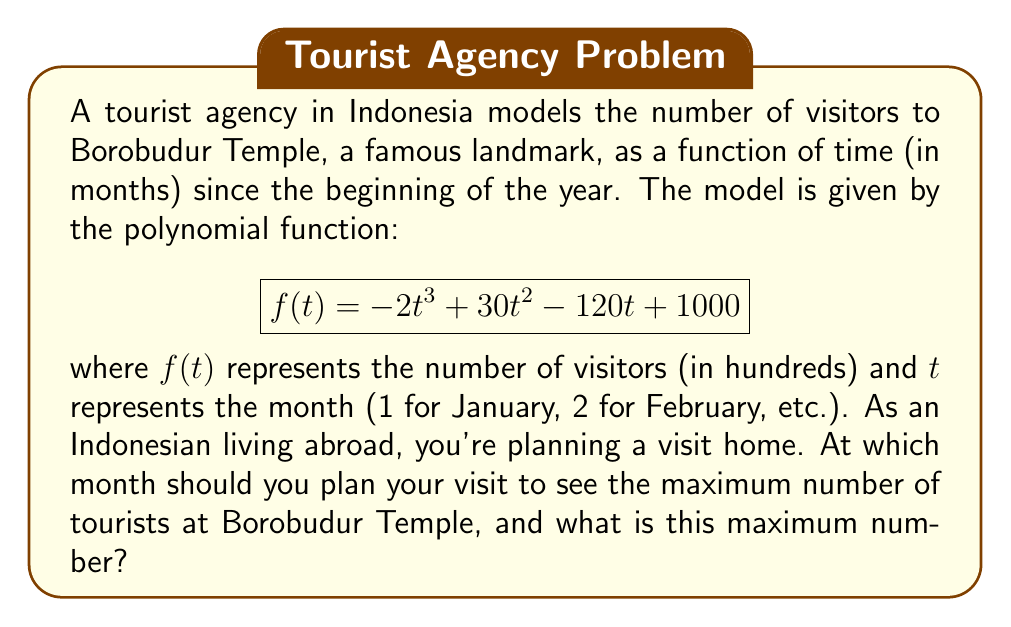Teach me how to tackle this problem. To find the maximum point of this polynomial curve, we need to follow these steps:

1) First, find the derivative of the function:
   $$f'(t) = -6t^2 + 60t - 120$$

2) Set the derivative equal to zero and solve for t:
   $$-6t^2 + 60t - 120 = 0$$
   $$-6(t^2 - 10t + 20) = 0$$
   $$-6(t - 5)^2 + 30 = 0$$
   $$(t - 5)^2 = 5$$
   $$t - 5 = \pm\sqrt{5}$$
   $$t = 5 \pm \sqrt{5}$$

3) The solutions are:
   $$t_1 = 5 + \sqrt{5} \approx 7.24$$
   $$t_2 = 5 - \sqrt{5} \approx 2.76$$

4) To determine which of these is the maximum, we can check the second derivative:
   $$f''(t) = -12t + 60$$
   
   At $t = 5 + \sqrt{5}$: $f''(5 + \sqrt{5}) < 0$
   At $t = 5 - \sqrt{5}$: $f''(5 - \sqrt{5}) > 0$

5) Since $f''(5 + \sqrt{5}) < 0$, this point is a maximum.

6) The maximum occurs at $t \approx 7.24$, which corresponds to early July.

7) To find the maximum number of visitors, we substitute this t-value back into the original function:

   $$f(7.24) = -2(7.24)^3 + 30(7.24)^2 - 120(7.24) + 1000 \approx 1544.29$$

Therefore, the maximum number of visitors is approximately 154,429.
Answer: Early July; 154,429 visitors 